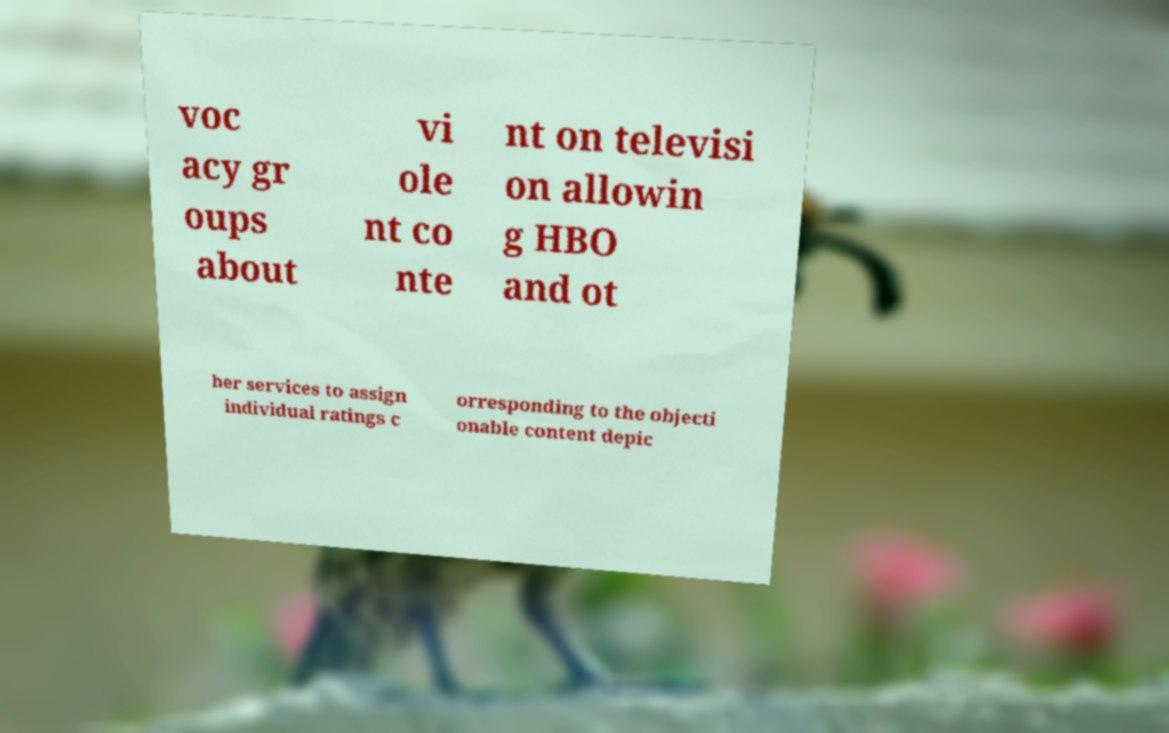Please read and relay the text visible in this image. What does it say? voc acy gr oups about vi ole nt co nte nt on televisi on allowin g HBO and ot her services to assign individual ratings c orresponding to the objecti onable content depic 